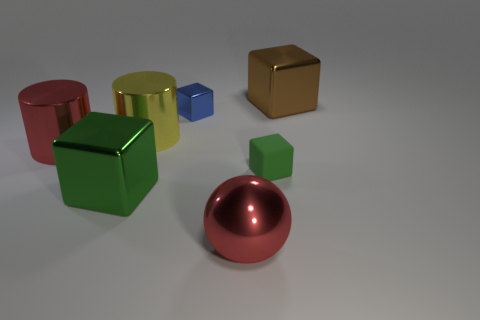Subtract all brown balls. How many green blocks are left? 2 Subtract 1 cubes. How many cubes are left? 3 Subtract all blue blocks. How many blocks are left? 3 Subtract all blue metal cubes. How many cubes are left? 3 Add 2 rubber objects. How many objects exist? 9 Subtract all purple blocks. Subtract all gray balls. How many blocks are left? 4 Subtract all spheres. How many objects are left? 6 Add 2 blue objects. How many blue objects exist? 3 Subtract 0 yellow blocks. How many objects are left? 7 Subtract all tiny green matte things. Subtract all tiny purple metal objects. How many objects are left? 6 